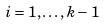Convert formula to latex. <formula><loc_0><loc_0><loc_500><loc_500>i = 1 , \dots , k - 1</formula> 